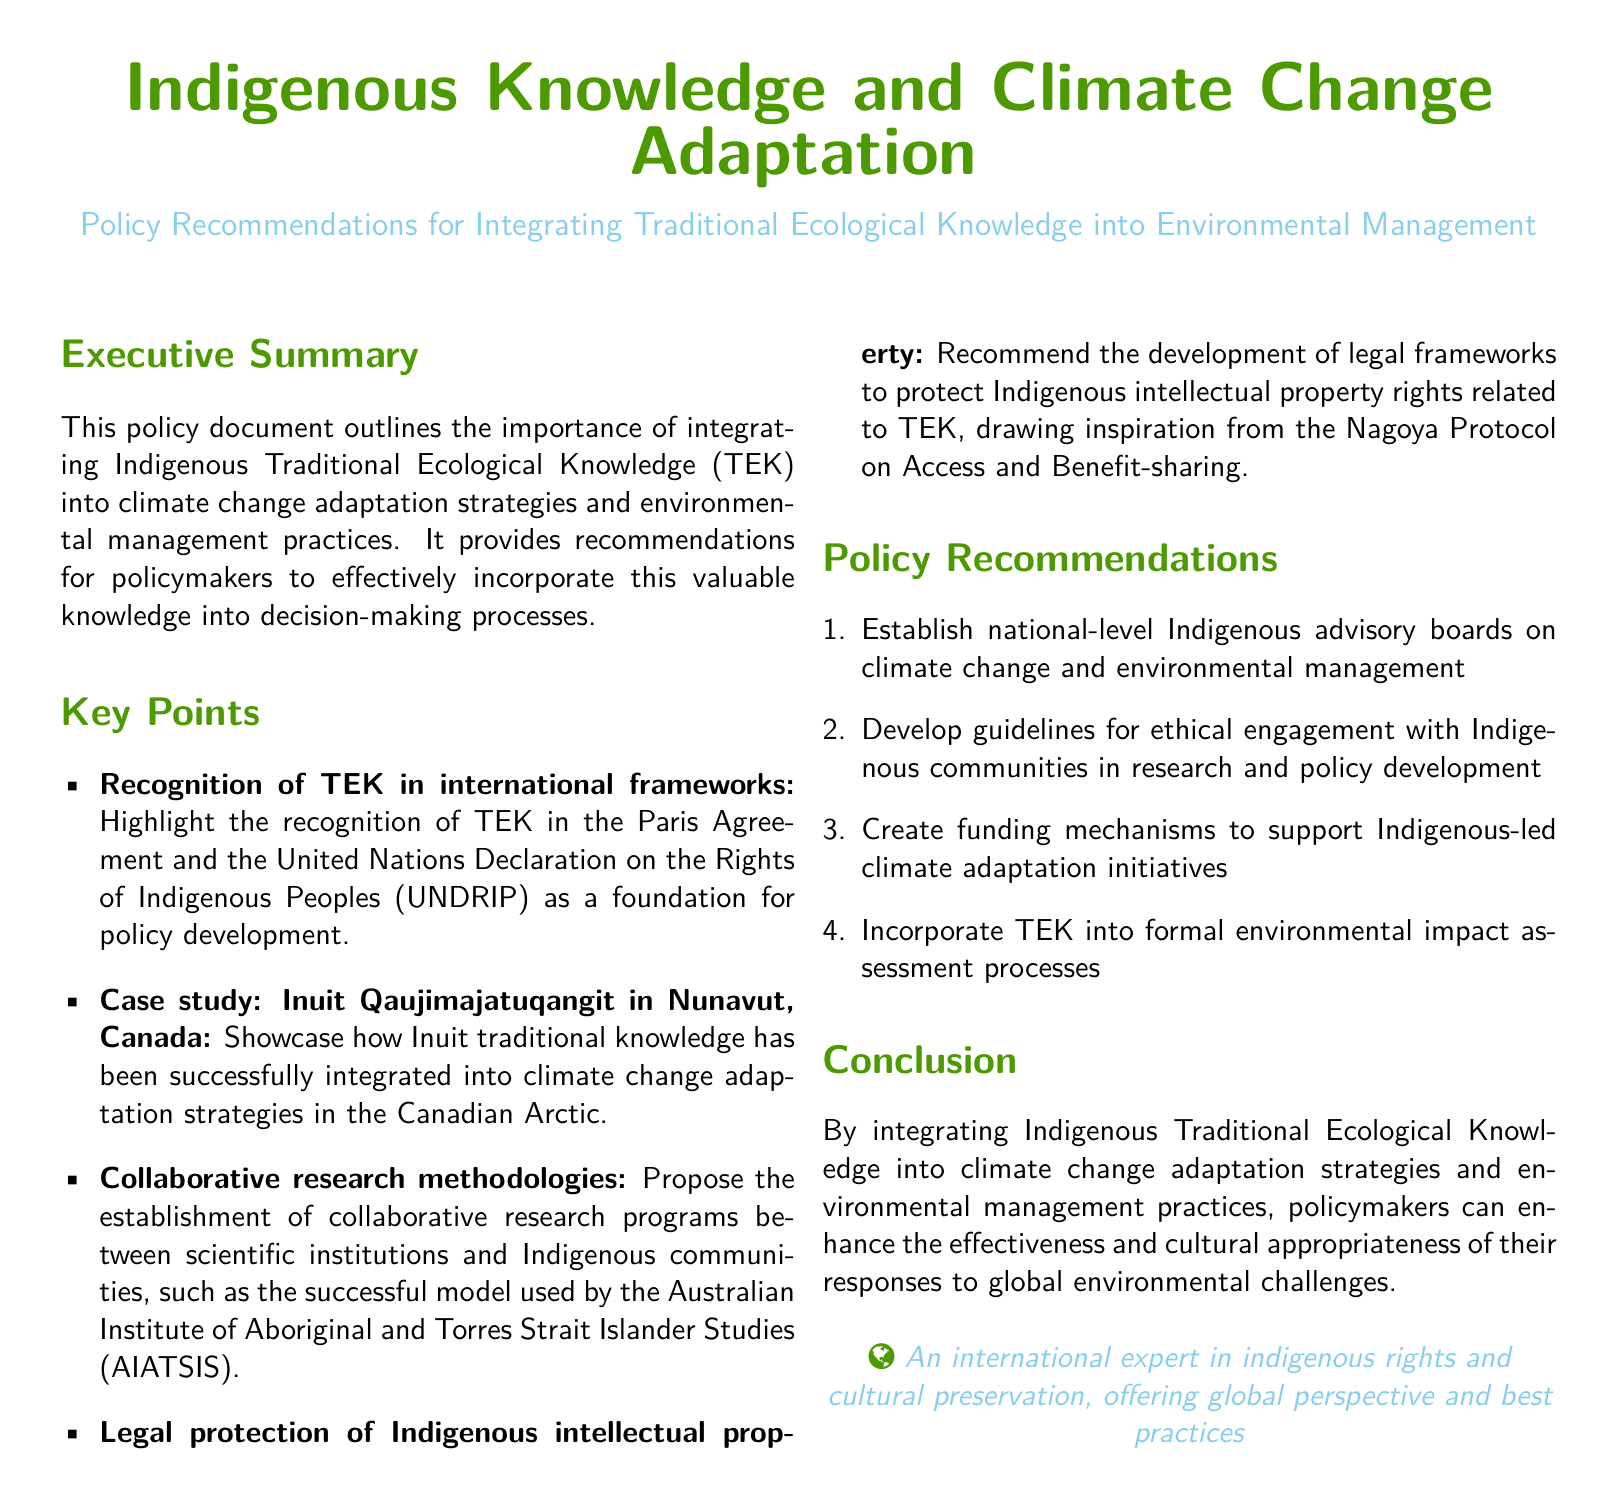what is the title of the document? The title appears prominently at the beginning of the document, which is "Indigenous Knowledge and Climate Change Adaptation."
Answer: Indigenous Knowledge and Climate Change Adaptation what is the purpose of the policy document? The executive summary outlines the purpose as integrating Indigenous Traditional Ecological Knowledge into climate change adaptation strategies and environmental management practices.
Answer: Integrating Indigenous Traditional Ecological Knowledge which international framework recognizes TEK? The document highlights the recognition of TEK in both the Paris Agreement and the United Nations Declaration on the Rights of Indigenous Peoples.
Answer: Paris Agreement and UNDRIP name a case study mentioned in the document. The document specifically mentions the Inuit Qaujimajatuqangit in Nunavut, Canada as a case study.
Answer: Inuit Qaujimajatuqangit in Nunavut how many policy recommendations are provided? The document lists a total of four policy recommendations for integrating TEK into environmental management.
Answer: Four what type of legal framework is recommended for protecting Indigenous rights? The document recommends developing legal frameworks inspired by the Nagoya Protocol on Access and Benefit-sharing.
Answer: Nagoya Protocol what is a proposed collaborative research methodology? The proposed methodology is the establishment of collaborative research programs between scientific institutions and Indigenous communities.
Answer: Collaborative research programs which organization has a successful model mentioned in the document? The document references the Australian Institute of Aboriginal and Torres Strait Islander Studies as having a successful model for collaborative research.
Answer: Australian Institute of Aboriginal and Torres Strait Islander Studies 